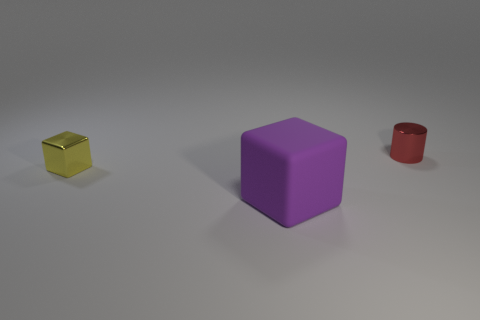Add 1 small red shiny objects. How many objects exist? 4 Subtract 0 cyan blocks. How many objects are left? 3 Subtract all cubes. How many objects are left? 1 Subtract all cubes. Subtract all small red cylinders. How many objects are left? 0 Add 3 purple rubber cubes. How many purple rubber cubes are left? 4 Add 2 small blue rubber spheres. How many small blue rubber spheres exist? 2 